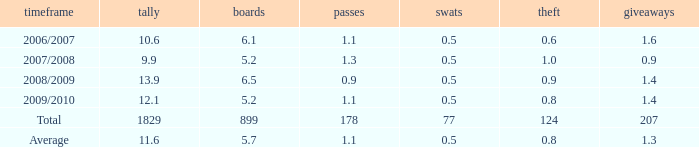What is the maximum rebounds when there are 0.9 steals and fewer than 1.4 turnovers? None. 